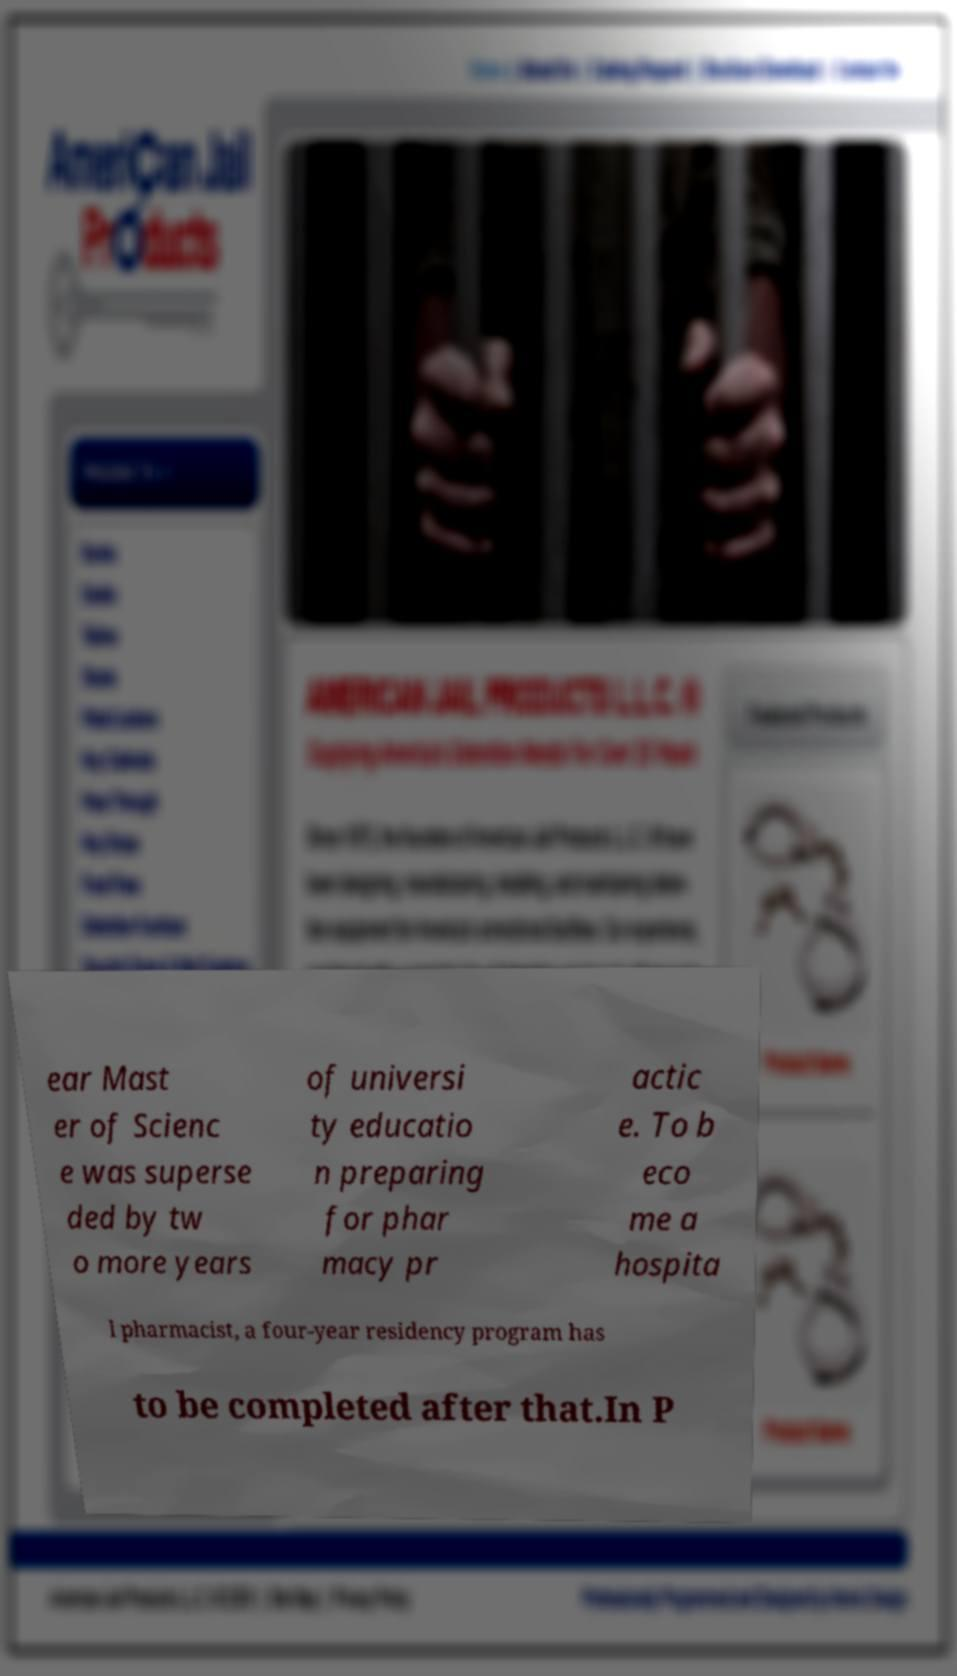There's text embedded in this image that I need extracted. Can you transcribe it verbatim? ear Mast er of Scienc e was superse ded by tw o more years of universi ty educatio n preparing for phar macy pr actic e. To b eco me a hospita l pharmacist, a four-year residency program has to be completed after that.In P 